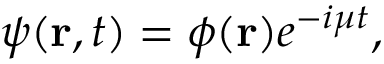<formula> <loc_0><loc_0><loc_500><loc_500>\psi ( { r } , t ) = \phi ( r ) e ^ { - i \mu t } ,</formula> 